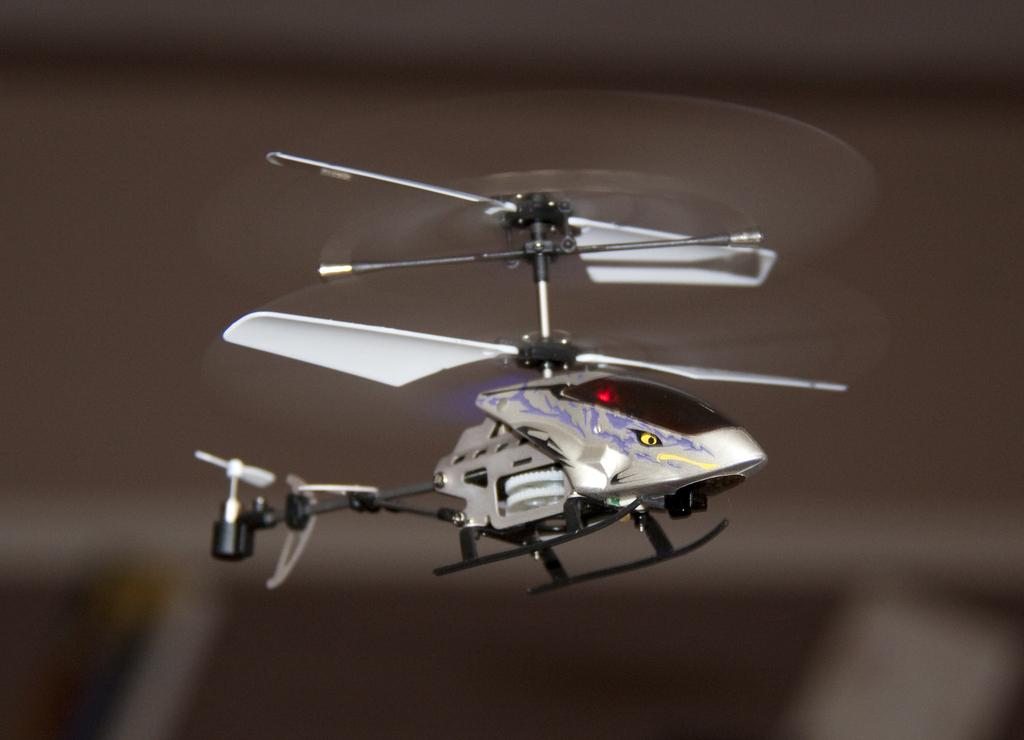What is the main subject of the image? There is a helicopter in the middle of the image. Can you describe the helicopter in more detail? Unfortunately, the provided facts do not offer any additional details about the helicopter. Is there anything else visible in the image besides the helicopter? The facts do not mention any other objects or subjects in the image. What type of vest is the helicopter wearing in the image? Helicopters do not wear vests, as they are inanimate objects. 